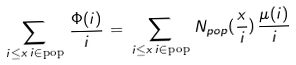<formula> <loc_0><loc_0><loc_500><loc_500>\sum _ { i \leq x \, i \in \text {pop} } \, \frac { \Phi ( i ) } { i } \, = \, \sum _ { i \leq x \, i \in \text {pop} } \, N _ { p o p } ( \frac { x } { i } ) \, \frac { \mu ( i ) } { i }</formula> 